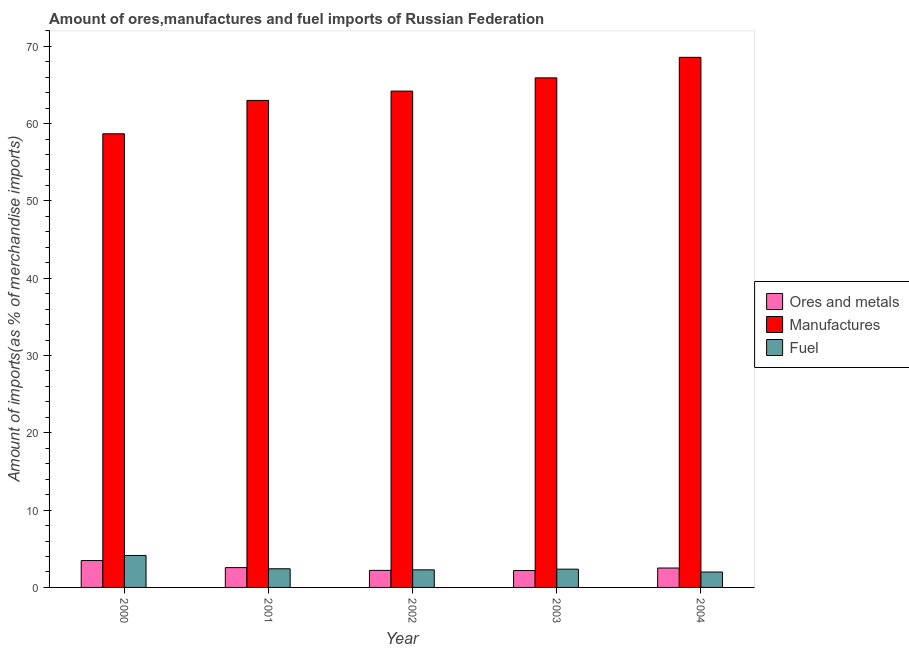Are the number of bars on each tick of the X-axis equal?
Ensure brevity in your answer.  Yes. What is the label of the 1st group of bars from the left?
Provide a short and direct response. 2000. In how many cases, is the number of bars for a given year not equal to the number of legend labels?
Offer a very short reply. 0. What is the percentage of ores and metals imports in 2002?
Offer a very short reply. 2.21. Across all years, what is the maximum percentage of manufactures imports?
Make the answer very short. 68.57. Across all years, what is the minimum percentage of manufactures imports?
Ensure brevity in your answer.  58.68. What is the total percentage of manufactures imports in the graph?
Ensure brevity in your answer.  320.37. What is the difference between the percentage of manufactures imports in 2002 and that in 2004?
Your response must be concise. -4.37. What is the difference between the percentage of ores and metals imports in 2000 and the percentage of manufactures imports in 2003?
Provide a short and direct response. 1.29. What is the average percentage of ores and metals imports per year?
Make the answer very short. 2.59. What is the ratio of the percentage of ores and metals imports in 2001 to that in 2003?
Keep it short and to the point. 1.17. Is the percentage of ores and metals imports in 2002 less than that in 2004?
Provide a short and direct response. Yes. Is the difference between the percentage of ores and metals imports in 2000 and 2002 greater than the difference between the percentage of fuel imports in 2000 and 2002?
Offer a terse response. No. What is the difference between the highest and the second highest percentage of ores and metals imports?
Your answer should be very brief. 0.91. What is the difference between the highest and the lowest percentage of ores and metals imports?
Ensure brevity in your answer.  1.29. In how many years, is the percentage of ores and metals imports greater than the average percentage of ores and metals imports taken over all years?
Your response must be concise. 1. Is the sum of the percentage of manufactures imports in 2003 and 2004 greater than the maximum percentage of ores and metals imports across all years?
Provide a short and direct response. Yes. What does the 1st bar from the left in 2003 represents?
Provide a short and direct response. Ores and metals. What does the 1st bar from the right in 2002 represents?
Offer a very short reply. Fuel. Is it the case that in every year, the sum of the percentage of ores and metals imports and percentage of manufactures imports is greater than the percentage of fuel imports?
Ensure brevity in your answer.  Yes. Are all the bars in the graph horizontal?
Keep it short and to the point. No. What is the difference between two consecutive major ticks on the Y-axis?
Provide a succinct answer. 10. Are the values on the major ticks of Y-axis written in scientific E-notation?
Give a very brief answer. No. Does the graph contain any zero values?
Your response must be concise. No. Where does the legend appear in the graph?
Give a very brief answer. Center right. How many legend labels are there?
Give a very brief answer. 3. How are the legend labels stacked?
Make the answer very short. Vertical. What is the title of the graph?
Your response must be concise. Amount of ores,manufactures and fuel imports of Russian Federation. Does "Coal sources" appear as one of the legend labels in the graph?
Make the answer very short. No. What is the label or title of the Y-axis?
Give a very brief answer. Amount of imports(as % of merchandise imports). What is the Amount of imports(as % of merchandise imports) of Ores and metals in 2000?
Give a very brief answer. 3.48. What is the Amount of imports(as % of merchandise imports) of Manufactures in 2000?
Offer a terse response. 58.68. What is the Amount of imports(as % of merchandise imports) of Fuel in 2000?
Give a very brief answer. 4.13. What is the Amount of imports(as % of merchandise imports) in Ores and metals in 2001?
Offer a very short reply. 2.56. What is the Amount of imports(as % of merchandise imports) of Manufactures in 2001?
Give a very brief answer. 63. What is the Amount of imports(as % of merchandise imports) in Fuel in 2001?
Offer a terse response. 2.41. What is the Amount of imports(as % of merchandise imports) of Ores and metals in 2002?
Your answer should be very brief. 2.21. What is the Amount of imports(as % of merchandise imports) of Manufactures in 2002?
Your answer should be very brief. 64.21. What is the Amount of imports(as % of merchandise imports) of Fuel in 2002?
Provide a succinct answer. 2.27. What is the Amount of imports(as % of merchandise imports) in Ores and metals in 2003?
Provide a succinct answer. 2.18. What is the Amount of imports(as % of merchandise imports) in Manufactures in 2003?
Give a very brief answer. 65.92. What is the Amount of imports(as % of merchandise imports) of Fuel in 2003?
Your answer should be compact. 2.36. What is the Amount of imports(as % of merchandise imports) of Ores and metals in 2004?
Your response must be concise. 2.51. What is the Amount of imports(as % of merchandise imports) of Manufactures in 2004?
Ensure brevity in your answer.  68.57. What is the Amount of imports(as % of merchandise imports) in Fuel in 2004?
Ensure brevity in your answer.  1.99. Across all years, what is the maximum Amount of imports(as % of merchandise imports) in Ores and metals?
Your answer should be compact. 3.48. Across all years, what is the maximum Amount of imports(as % of merchandise imports) in Manufactures?
Offer a very short reply. 68.57. Across all years, what is the maximum Amount of imports(as % of merchandise imports) of Fuel?
Your answer should be very brief. 4.13. Across all years, what is the minimum Amount of imports(as % of merchandise imports) of Ores and metals?
Your response must be concise. 2.18. Across all years, what is the minimum Amount of imports(as % of merchandise imports) of Manufactures?
Provide a short and direct response. 58.68. Across all years, what is the minimum Amount of imports(as % of merchandise imports) in Fuel?
Offer a very short reply. 1.99. What is the total Amount of imports(as % of merchandise imports) in Ores and metals in the graph?
Ensure brevity in your answer.  12.94. What is the total Amount of imports(as % of merchandise imports) in Manufactures in the graph?
Keep it short and to the point. 320.37. What is the total Amount of imports(as % of merchandise imports) in Fuel in the graph?
Offer a terse response. 13.17. What is the difference between the Amount of imports(as % of merchandise imports) in Ores and metals in 2000 and that in 2001?
Make the answer very short. 0.91. What is the difference between the Amount of imports(as % of merchandise imports) of Manufactures in 2000 and that in 2001?
Keep it short and to the point. -4.32. What is the difference between the Amount of imports(as % of merchandise imports) in Fuel in 2000 and that in 2001?
Provide a succinct answer. 1.72. What is the difference between the Amount of imports(as % of merchandise imports) in Ores and metals in 2000 and that in 2002?
Provide a succinct answer. 1.27. What is the difference between the Amount of imports(as % of merchandise imports) in Manufactures in 2000 and that in 2002?
Give a very brief answer. -5.53. What is the difference between the Amount of imports(as % of merchandise imports) in Fuel in 2000 and that in 2002?
Provide a succinct answer. 1.86. What is the difference between the Amount of imports(as % of merchandise imports) in Ores and metals in 2000 and that in 2003?
Your answer should be compact. 1.29. What is the difference between the Amount of imports(as % of merchandise imports) of Manufactures in 2000 and that in 2003?
Offer a terse response. -7.24. What is the difference between the Amount of imports(as % of merchandise imports) of Fuel in 2000 and that in 2003?
Ensure brevity in your answer.  1.77. What is the difference between the Amount of imports(as % of merchandise imports) in Manufactures in 2000 and that in 2004?
Your response must be concise. -9.89. What is the difference between the Amount of imports(as % of merchandise imports) of Fuel in 2000 and that in 2004?
Ensure brevity in your answer.  2.14. What is the difference between the Amount of imports(as % of merchandise imports) of Ores and metals in 2001 and that in 2002?
Provide a succinct answer. 0.36. What is the difference between the Amount of imports(as % of merchandise imports) of Manufactures in 2001 and that in 2002?
Keep it short and to the point. -1.21. What is the difference between the Amount of imports(as % of merchandise imports) in Fuel in 2001 and that in 2002?
Provide a succinct answer. 0.14. What is the difference between the Amount of imports(as % of merchandise imports) in Ores and metals in 2001 and that in 2003?
Provide a short and direct response. 0.38. What is the difference between the Amount of imports(as % of merchandise imports) in Manufactures in 2001 and that in 2003?
Your answer should be compact. -2.92. What is the difference between the Amount of imports(as % of merchandise imports) of Fuel in 2001 and that in 2003?
Offer a terse response. 0.05. What is the difference between the Amount of imports(as % of merchandise imports) of Ores and metals in 2001 and that in 2004?
Provide a short and direct response. 0.05. What is the difference between the Amount of imports(as % of merchandise imports) of Manufactures in 2001 and that in 2004?
Keep it short and to the point. -5.57. What is the difference between the Amount of imports(as % of merchandise imports) in Fuel in 2001 and that in 2004?
Your answer should be compact. 0.42. What is the difference between the Amount of imports(as % of merchandise imports) of Ores and metals in 2002 and that in 2003?
Your answer should be compact. 0.02. What is the difference between the Amount of imports(as % of merchandise imports) in Manufactures in 2002 and that in 2003?
Keep it short and to the point. -1.71. What is the difference between the Amount of imports(as % of merchandise imports) of Fuel in 2002 and that in 2003?
Ensure brevity in your answer.  -0.09. What is the difference between the Amount of imports(as % of merchandise imports) of Ores and metals in 2002 and that in 2004?
Your answer should be very brief. -0.3. What is the difference between the Amount of imports(as % of merchandise imports) in Manufactures in 2002 and that in 2004?
Offer a very short reply. -4.37. What is the difference between the Amount of imports(as % of merchandise imports) in Fuel in 2002 and that in 2004?
Your response must be concise. 0.28. What is the difference between the Amount of imports(as % of merchandise imports) of Ores and metals in 2003 and that in 2004?
Your answer should be compact. -0.32. What is the difference between the Amount of imports(as % of merchandise imports) of Manufactures in 2003 and that in 2004?
Provide a succinct answer. -2.66. What is the difference between the Amount of imports(as % of merchandise imports) in Fuel in 2003 and that in 2004?
Make the answer very short. 0.37. What is the difference between the Amount of imports(as % of merchandise imports) of Ores and metals in 2000 and the Amount of imports(as % of merchandise imports) of Manufactures in 2001?
Keep it short and to the point. -59.52. What is the difference between the Amount of imports(as % of merchandise imports) in Ores and metals in 2000 and the Amount of imports(as % of merchandise imports) in Fuel in 2001?
Your answer should be very brief. 1.06. What is the difference between the Amount of imports(as % of merchandise imports) of Manufactures in 2000 and the Amount of imports(as % of merchandise imports) of Fuel in 2001?
Your answer should be very brief. 56.27. What is the difference between the Amount of imports(as % of merchandise imports) in Ores and metals in 2000 and the Amount of imports(as % of merchandise imports) in Manufactures in 2002?
Make the answer very short. -60.73. What is the difference between the Amount of imports(as % of merchandise imports) in Ores and metals in 2000 and the Amount of imports(as % of merchandise imports) in Fuel in 2002?
Offer a very short reply. 1.2. What is the difference between the Amount of imports(as % of merchandise imports) of Manufactures in 2000 and the Amount of imports(as % of merchandise imports) of Fuel in 2002?
Offer a terse response. 56.41. What is the difference between the Amount of imports(as % of merchandise imports) of Ores and metals in 2000 and the Amount of imports(as % of merchandise imports) of Manufactures in 2003?
Make the answer very short. -62.44. What is the difference between the Amount of imports(as % of merchandise imports) in Ores and metals in 2000 and the Amount of imports(as % of merchandise imports) in Fuel in 2003?
Your answer should be very brief. 1.12. What is the difference between the Amount of imports(as % of merchandise imports) in Manufactures in 2000 and the Amount of imports(as % of merchandise imports) in Fuel in 2003?
Keep it short and to the point. 56.32. What is the difference between the Amount of imports(as % of merchandise imports) in Ores and metals in 2000 and the Amount of imports(as % of merchandise imports) in Manufactures in 2004?
Your answer should be compact. -65.1. What is the difference between the Amount of imports(as % of merchandise imports) in Ores and metals in 2000 and the Amount of imports(as % of merchandise imports) in Fuel in 2004?
Keep it short and to the point. 1.49. What is the difference between the Amount of imports(as % of merchandise imports) in Manufactures in 2000 and the Amount of imports(as % of merchandise imports) in Fuel in 2004?
Give a very brief answer. 56.69. What is the difference between the Amount of imports(as % of merchandise imports) of Ores and metals in 2001 and the Amount of imports(as % of merchandise imports) of Manufactures in 2002?
Keep it short and to the point. -61.64. What is the difference between the Amount of imports(as % of merchandise imports) of Ores and metals in 2001 and the Amount of imports(as % of merchandise imports) of Fuel in 2002?
Your answer should be compact. 0.29. What is the difference between the Amount of imports(as % of merchandise imports) of Manufactures in 2001 and the Amount of imports(as % of merchandise imports) of Fuel in 2002?
Ensure brevity in your answer.  60.72. What is the difference between the Amount of imports(as % of merchandise imports) of Ores and metals in 2001 and the Amount of imports(as % of merchandise imports) of Manufactures in 2003?
Your answer should be compact. -63.35. What is the difference between the Amount of imports(as % of merchandise imports) of Ores and metals in 2001 and the Amount of imports(as % of merchandise imports) of Fuel in 2003?
Provide a succinct answer. 0.2. What is the difference between the Amount of imports(as % of merchandise imports) in Manufactures in 2001 and the Amount of imports(as % of merchandise imports) in Fuel in 2003?
Make the answer very short. 60.64. What is the difference between the Amount of imports(as % of merchandise imports) of Ores and metals in 2001 and the Amount of imports(as % of merchandise imports) of Manufactures in 2004?
Provide a short and direct response. -66.01. What is the difference between the Amount of imports(as % of merchandise imports) in Ores and metals in 2001 and the Amount of imports(as % of merchandise imports) in Fuel in 2004?
Keep it short and to the point. 0.57. What is the difference between the Amount of imports(as % of merchandise imports) in Manufactures in 2001 and the Amount of imports(as % of merchandise imports) in Fuel in 2004?
Provide a short and direct response. 61.01. What is the difference between the Amount of imports(as % of merchandise imports) of Ores and metals in 2002 and the Amount of imports(as % of merchandise imports) of Manufactures in 2003?
Ensure brevity in your answer.  -63.71. What is the difference between the Amount of imports(as % of merchandise imports) in Ores and metals in 2002 and the Amount of imports(as % of merchandise imports) in Fuel in 2003?
Your answer should be compact. -0.15. What is the difference between the Amount of imports(as % of merchandise imports) in Manufactures in 2002 and the Amount of imports(as % of merchandise imports) in Fuel in 2003?
Offer a very short reply. 61.84. What is the difference between the Amount of imports(as % of merchandise imports) of Ores and metals in 2002 and the Amount of imports(as % of merchandise imports) of Manufactures in 2004?
Keep it short and to the point. -66.36. What is the difference between the Amount of imports(as % of merchandise imports) in Ores and metals in 2002 and the Amount of imports(as % of merchandise imports) in Fuel in 2004?
Keep it short and to the point. 0.22. What is the difference between the Amount of imports(as % of merchandise imports) of Manufactures in 2002 and the Amount of imports(as % of merchandise imports) of Fuel in 2004?
Provide a short and direct response. 62.22. What is the difference between the Amount of imports(as % of merchandise imports) in Ores and metals in 2003 and the Amount of imports(as % of merchandise imports) in Manufactures in 2004?
Keep it short and to the point. -66.39. What is the difference between the Amount of imports(as % of merchandise imports) of Ores and metals in 2003 and the Amount of imports(as % of merchandise imports) of Fuel in 2004?
Offer a very short reply. 0.19. What is the difference between the Amount of imports(as % of merchandise imports) of Manufactures in 2003 and the Amount of imports(as % of merchandise imports) of Fuel in 2004?
Your response must be concise. 63.93. What is the average Amount of imports(as % of merchandise imports) in Ores and metals per year?
Offer a terse response. 2.59. What is the average Amount of imports(as % of merchandise imports) in Manufactures per year?
Give a very brief answer. 64.07. What is the average Amount of imports(as % of merchandise imports) of Fuel per year?
Make the answer very short. 2.63. In the year 2000, what is the difference between the Amount of imports(as % of merchandise imports) in Ores and metals and Amount of imports(as % of merchandise imports) in Manufactures?
Make the answer very short. -55.2. In the year 2000, what is the difference between the Amount of imports(as % of merchandise imports) of Ores and metals and Amount of imports(as % of merchandise imports) of Fuel?
Your response must be concise. -0.66. In the year 2000, what is the difference between the Amount of imports(as % of merchandise imports) in Manufactures and Amount of imports(as % of merchandise imports) in Fuel?
Your answer should be very brief. 54.55. In the year 2001, what is the difference between the Amount of imports(as % of merchandise imports) in Ores and metals and Amount of imports(as % of merchandise imports) in Manufactures?
Your answer should be compact. -60.44. In the year 2001, what is the difference between the Amount of imports(as % of merchandise imports) in Ores and metals and Amount of imports(as % of merchandise imports) in Fuel?
Provide a short and direct response. 0.15. In the year 2001, what is the difference between the Amount of imports(as % of merchandise imports) of Manufactures and Amount of imports(as % of merchandise imports) of Fuel?
Your answer should be compact. 60.59. In the year 2002, what is the difference between the Amount of imports(as % of merchandise imports) of Ores and metals and Amount of imports(as % of merchandise imports) of Manufactures?
Give a very brief answer. -62. In the year 2002, what is the difference between the Amount of imports(as % of merchandise imports) of Ores and metals and Amount of imports(as % of merchandise imports) of Fuel?
Provide a short and direct response. -0.07. In the year 2002, what is the difference between the Amount of imports(as % of merchandise imports) in Manufactures and Amount of imports(as % of merchandise imports) in Fuel?
Give a very brief answer. 61.93. In the year 2003, what is the difference between the Amount of imports(as % of merchandise imports) of Ores and metals and Amount of imports(as % of merchandise imports) of Manufactures?
Your answer should be compact. -63.73. In the year 2003, what is the difference between the Amount of imports(as % of merchandise imports) of Ores and metals and Amount of imports(as % of merchandise imports) of Fuel?
Ensure brevity in your answer.  -0.18. In the year 2003, what is the difference between the Amount of imports(as % of merchandise imports) of Manufactures and Amount of imports(as % of merchandise imports) of Fuel?
Provide a succinct answer. 63.55. In the year 2004, what is the difference between the Amount of imports(as % of merchandise imports) in Ores and metals and Amount of imports(as % of merchandise imports) in Manufactures?
Provide a short and direct response. -66.06. In the year 2004, what is the difference between the Amount of imports(as % of merchandise imports) in Ores and metals and Amount of imports(as % of merchandise imports) in Fuel?
Keep it short and to the point. 0.52. In the year 2004, what is the difference between the Amount of imports(as % of merchandise imports) in Manufactures and Amount of imports(as % of merchandise imports) in Fuel?
Give a very brief answer. 66.58. What is the ratio of the Amount of imports(as % of merchandise imports) in Ores and metals in 2000 to that in 2001?
Provide a succinct answer. 1.36. What is the ratio of the Amount of imports(as % of merchandise imports) of Manufactures in 2000 to that in 2001?
Provide a succinct answer. 0.93. What is the ratio of the Amount of imports(as % of merchandise imports) of Fuel in 2000 to that in 2001?
Offer a very short reply. 1.71. What is the ratio of the Amount of imports(as % of merchandise imports) of Ores and metals in 2000 to that in 2002?
Provide a short and direct response. 1.58. What is the ratio of the Amount of imports(as % of merchandise imports) of Manufactures in 2000 to that in 2002?
Provide a succinct answer. 0.91. What is the ratio of the Amount of imports(as % of merchandise imports) of Fuel in 2000 to that in 2002?
Offer a very short reply. 1.82. What is the ratio of the Amount of imports(as % of merchandise imports) of Ores and metals in 2000 to that in 2003?
Ensure brevity in your answer.  1.59. What is the ratio of the Amount of imports(as % of merchandise imports) of Manufactures in 2000 to that in 2003?
Provide a short and direct response. 0.89. What is the ratio of the Amount of imports(as % of merchandise imports) in Fuel in 2000 to that in 2003?
Make the answer very short. 1.75. What is the ratio of the Amount of imports(as % of merchandise imports) of Ores and metals in 2000 to that in 2004?
Make the answer very short. 1.39. What is the ratio of the Amount of imports(as % of merchandise imports) in Manufactures in 2000 to that in 2004?
Your response must be concise. 0.86. What is the ratio of the Amount of imports(as % of merchandise imports) in Fuel in 2000 to that in 2004?
Provide a short and direct response. 2.08. What is the ratio of the Amount of imports(as % of merchandise imports) of Ores and metals in 2001 to that in 2002?
Offer a terse response. 1.16. What is the ratio of the Amount of imports(as % of merchandise imports) of Manufactures in 2001 to that in 2002?
Provide a short and direct response. 0.98. What is the ratio of the Amount of imports(as % of merchandise imports) in Fuel in 2001 to that in 2002?
Provide a succinct answer. 1.06. What is the ratio of the Amount of imports(as % of merchandise imports) of Ores and metals in 2001 to that in 2003?
Offer a terse response. 1.17. What is the ratio of the Amount of imports(as % of merchandise imports) of Manufactures in 2001 to that in 2003?
Give a very brief answer. 0.96. What is the ratio of the Amount of imports(as % of merchandise imports) of Fuel in 2001 to that in 2003?
Offer a terse response. 1.02. What is the ratio of the Amount of imports(as % of merchandise imports) in Ores and metals in 2001 to that in 2004?
Ensure brevity in your answer.  1.02. What is the ratio of the Amount of imports(as % of merchandise imports) of Manufactures in 2001 to that in 2004?
Ensure brevity in your answer.  0.92. What is the ratio of the Amount of imports(as % of merchandise imports) in Fuel in 2001 to that in 2004?
Make the answer very short. 1.21. What is the ratio of the Amount of imports(as % of merchandise imports) of Ores and metals in 2002 to that in 2003?
Offer a terse response. 1.01. What is the ratio of the Amount of imports(as % of merchandise imports) in Manufactures in 2002 to that in 2003?
Your answer should be very brief. 0.97. What is the ratio of the Amount of imports(as % of merchandise imports) of Fuel in 2002 to that in 2003?
Offer a very short reply. 0.96. What is the ratio of the Amount of imports(as % of merchandise imports) in Ores and metals in 2002 to that in 2004?
Your answer should be compact. 0.88. What is the ratio of the Amount of imports(as % of merchandise imports) of Manufactures in 2002 to that in 2004?
Offer a very short reply. 0.94. What is the ratio of the Amount of imports(as % of merchandise imports) of Fuel in 2002 to that in 2004?
Your response must be concise. 1.14. What is the ratio of the Amount of imports(as % of merchandise imports) in Ores and metals in 2003 to that in 2004?
Your response must be concise. 0.87. What is the ratio of the Amount of imports(as % of merchandise imports) in Manufactures in 2003 to that in 2004?
Offer a terse response. 0.96. What is the ratio of the Amount of imports(as % of merchandise imports) in Fuel in 2003 to that in 2004?
Your answer should be compact. 1.19. What is the difference between the highest and the second highest Amount of imports(as % of merchandise imports) of Ores and metals?
Give a very brief answer. 0.91. What is the difference between the highest and the second highest Amount of imports(as % of merchandise imports) of Manufactures?
Make the answer very short. 2.66. What is the difference between the highest and the second highest Amount of imports(as % of merchandise imports) in Fuel?
Your answer should be very brief. 1.72. What is the difference between the highest and the lowest Amount of imports(as % of merchandise imports) in Ores and metals?
Ensure brevity in your answer.  1.29. What is the difference between the highest and the lowest Amount of imports(as % of merchandise imports) of Manufactures?
Your response must be concise. 9.89. What is the difference between the highest and the lowest Amount of imports(as % of merchandise imports) in Fuel?
Make the answer very short. 2.14. 